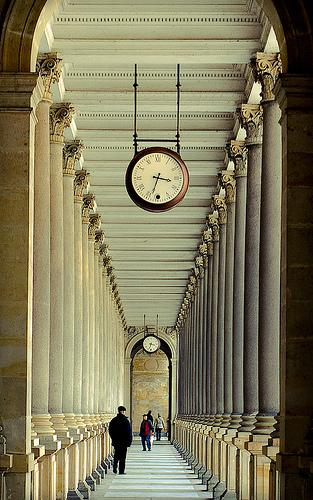Mention the primary object and its distinctive features in the image. A man in all black with a hat is standing in a long, pillared hallway with a large clock hanging from the ceiling.  Describe the architectural elements present in the image. The image features a long hallway with rows of large pillars on either side, arched doorways, decorative column tops, and a high ceiling with clocks. How would you describe the location in the image and its inhabitants? The location is an impressive hall with large pillars and clocks, inhabited by people wearing various outfits, such as a man in all black with a hat. Please describe the atmosphere and the main elements in the picture. It's a historical architectural setting with rows of pillars on either side and people walking down the long hallway, where clocks are hanging from the ceiling. Provide a short explanation of the key details of the image. The image shows people interacting in a grand hall with rows of big pillars and hanging clocks, some wearing notable attire. Mention the main elements in the image and how they come together. Rows of big pillars, hanging clocks, and people walking and standing create a lively atmosphere in a historical, architectural setting. Mention the activities the people in the image are engaged in. People in the image are walking, standing, and conversing in a long, pillared hallway with large hanging clocks. Describe any noteworthy details or aspects in the image. The image features a man in all black with a hat and a short man in a red shirt, among other people, in a long hallway with tall pillars and hanging clocks. Provide a concise overview of the scene in the image. People walk and stand in a hallway with tall pillars, big clocks, and some individuals wearing distinctive attire. List the various activities, clothing, and objects shown in the image. Activities: walking, standing. Clothing: black hat, red shirt, black coat, black jacket. Objects: large pillars, hanging clocks, floor, ceiling. 